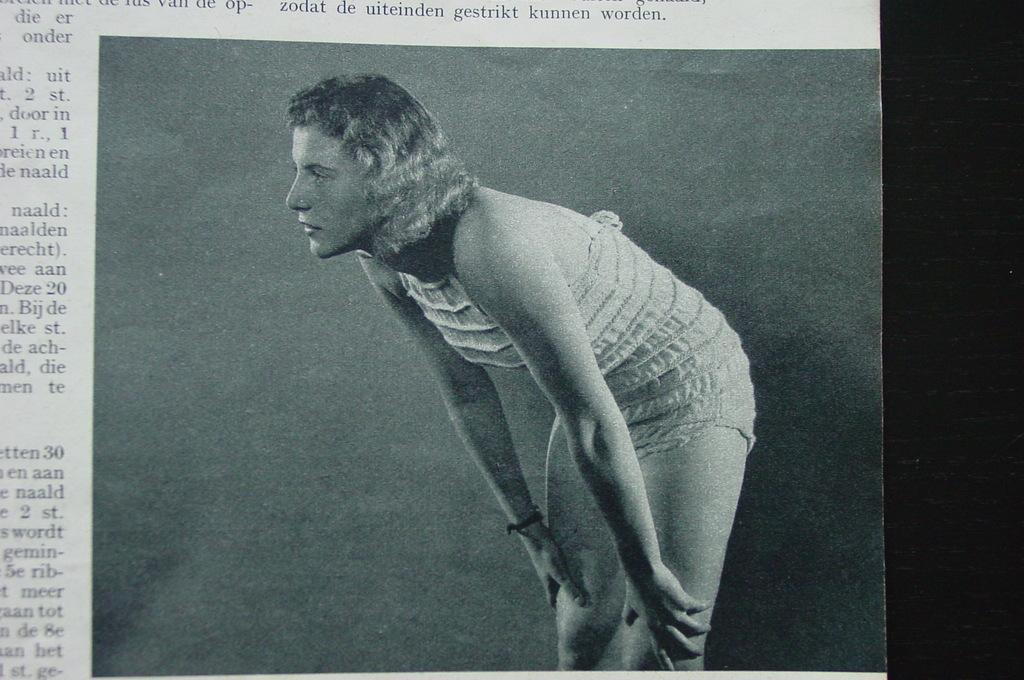What is the color scheme of the image? The image is black and white. Who or what is the main subject in the image? There is a lady in the center of the image, bending. What can be seen in the background of the image? There is text visible in the background of the image. What type of collar can be seen on the floor in the image? There is no collar visible on the floor in the image. 